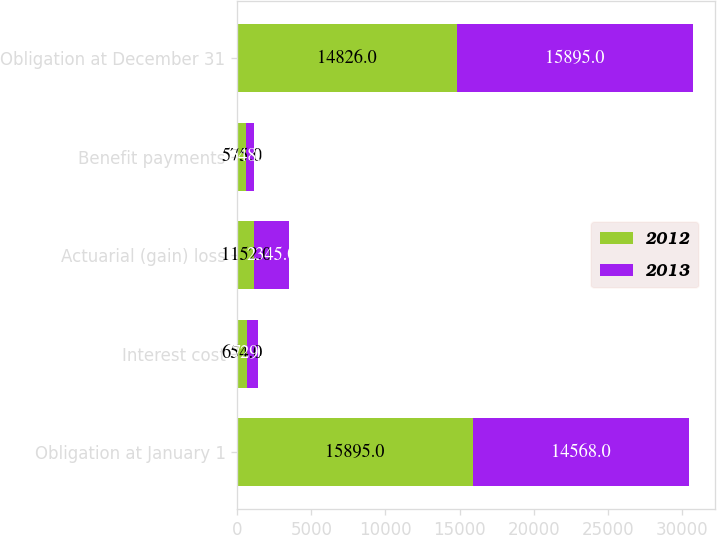<chart> <loc_0><loc_0><loc_500><loc_500><stacked_bar_chart><ecel><fcel>Obligation at January 1<fcel>Interest cost<fcel>Actuarial (gain) loss<fcel>Benefit payments<fcel>Obligation at December 31<nl><fcel>2012<fcel>15895<fcel>654<fcel>1152<fcel>575<fcel>14826<nl><fcel>2013<fcel>14568<fcel>729<fcel>2345<fcel>548<fcel>15895<nl></chart> 